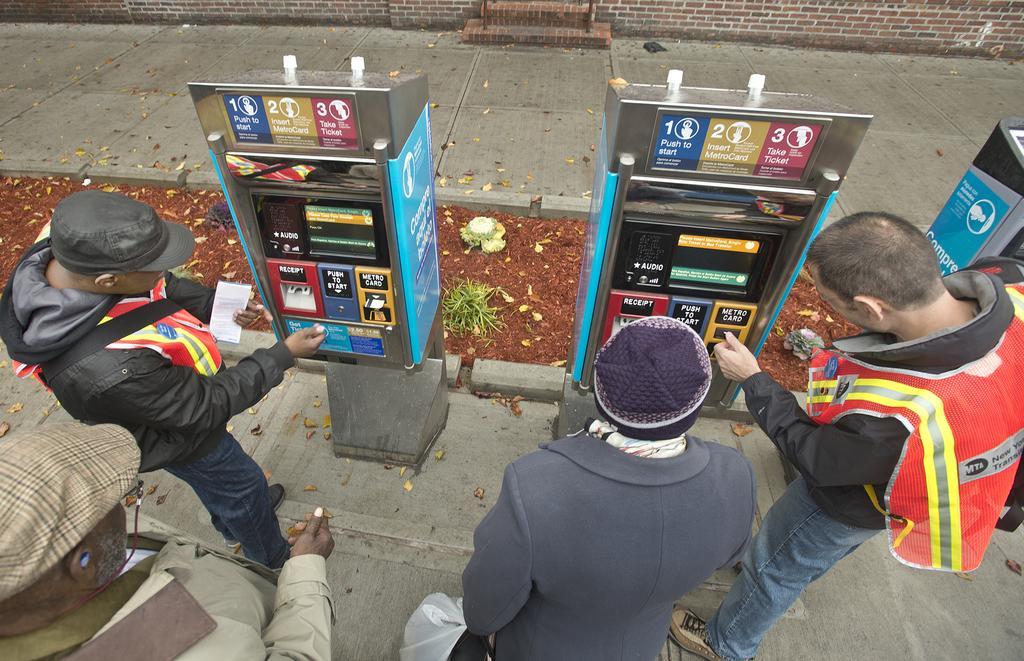Please provide a concise description of this image. At the bottom of this image I can see for men are standing in front of machines which are placed on the road. It seems like ATM. On the top of a image I can see a wall. 